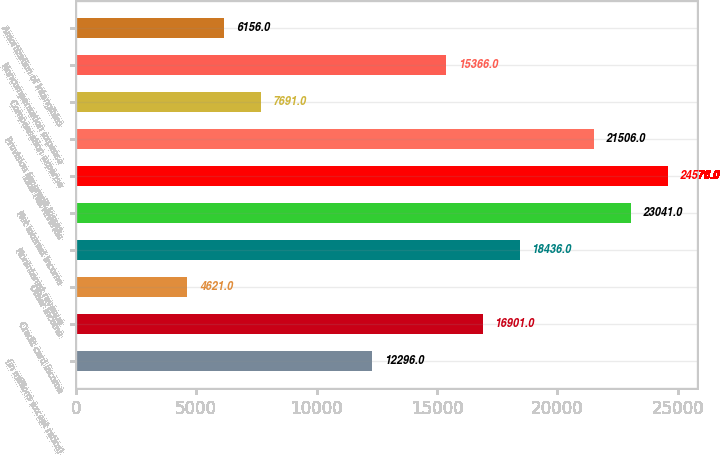Convert chart. <chart><loc_0><loc_0><loc_500><loc_500><bar_chart><fcel>(in millions except ratios)<fcel>Credit card income<fcel>Other income<fcel>Noninterest revenue<fcel>Net interest income<fcel>Total net revenue<fcel>Provision for credit losses<fcel>Compensation expense<fcel>Noncompensation expense<fcel>Amortization of intangibles<nl><fcel>12296<fcel>16901<fcel>4621<fcel>18436<fcel>23041<fcel>24576<fcel>21506<fcel>7691<fcel>15366<fcel>6156<nl></chart> 